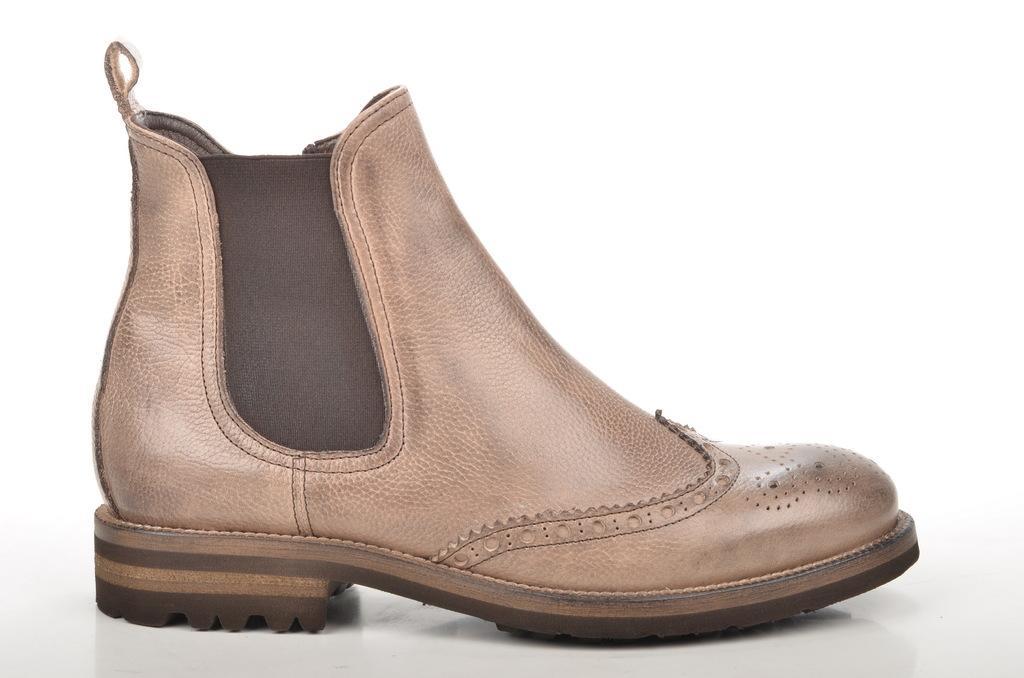Describe this image in one or two sentences. In this image we can see a boot which is placed on the surface. 